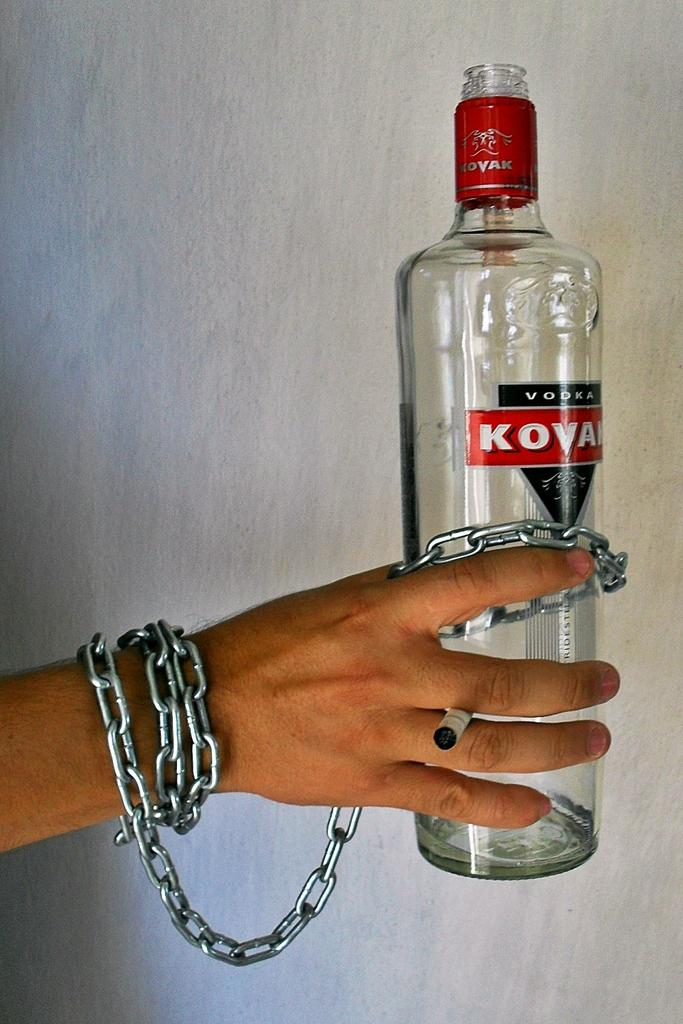Who or what is present in the image? There is a person in the image. What is the person holding in their hand? The person is holding a bottle and a chain. What type of offer is the person making in the image? There is no indication in the image that the person is making any offer. 